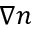<formula> <loc_0><loc_0><loc_500><loc_500>\nabla n</formula> 